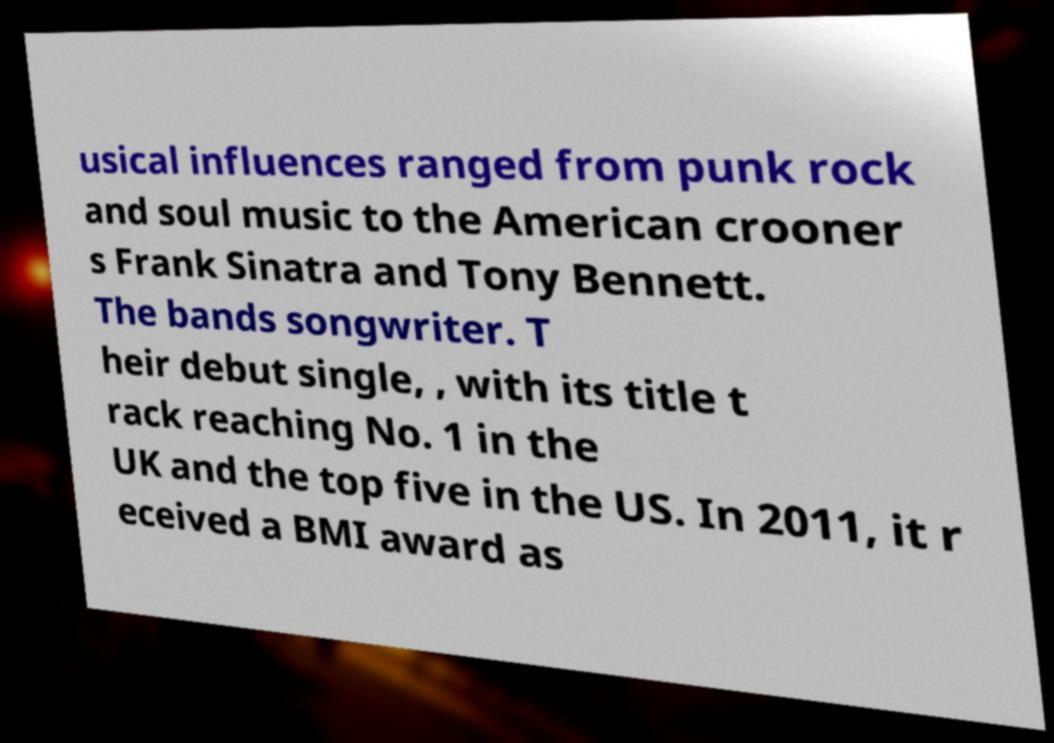Please identify and transcribe the text found in this image. usical influences ranged from punk rock and soul music to the American crooner s Frank Sinatra and Tony Bennett. The bands songwriter. T heir debut single, , with its title t rack reaching No. 1 in the UK and the top five in the US. In 2011, it r eceived a BMI award as 